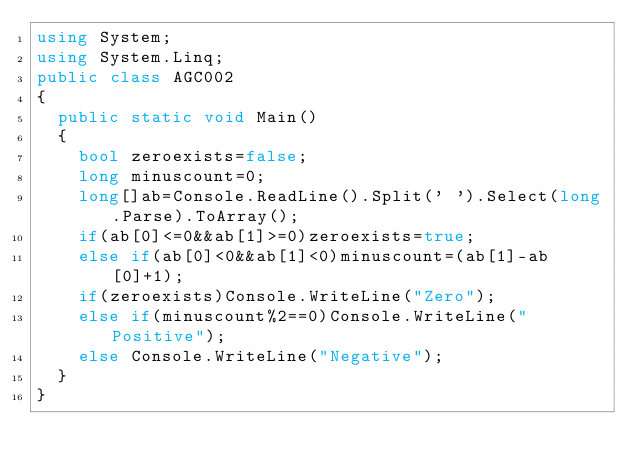<code> <loc_0><loc_0><loc_500><loc_500><_C#_>using System;
using System.Linq;
public class AGC002
{
  public static void Main()
  {
    bool zeroexists=false;
    long minuscount=0;
    long[]ab=Console.ReadLine().Split(' ').Select(long.Parse).ToArray();
    if(ab[0]<=0&&ab[1]>=0)zeroexists=true;
    else if(ab[0]<0&&ab[1]<0)minuscount=(ab[1]-ab[0]+1);
    if(zeroexists)Console.WriteLine("Zero");
    else if(minuscount%2==0)Console.WriteLine("Positive");
    else Console.WriteLine("Negative");
  }
}
</code> 